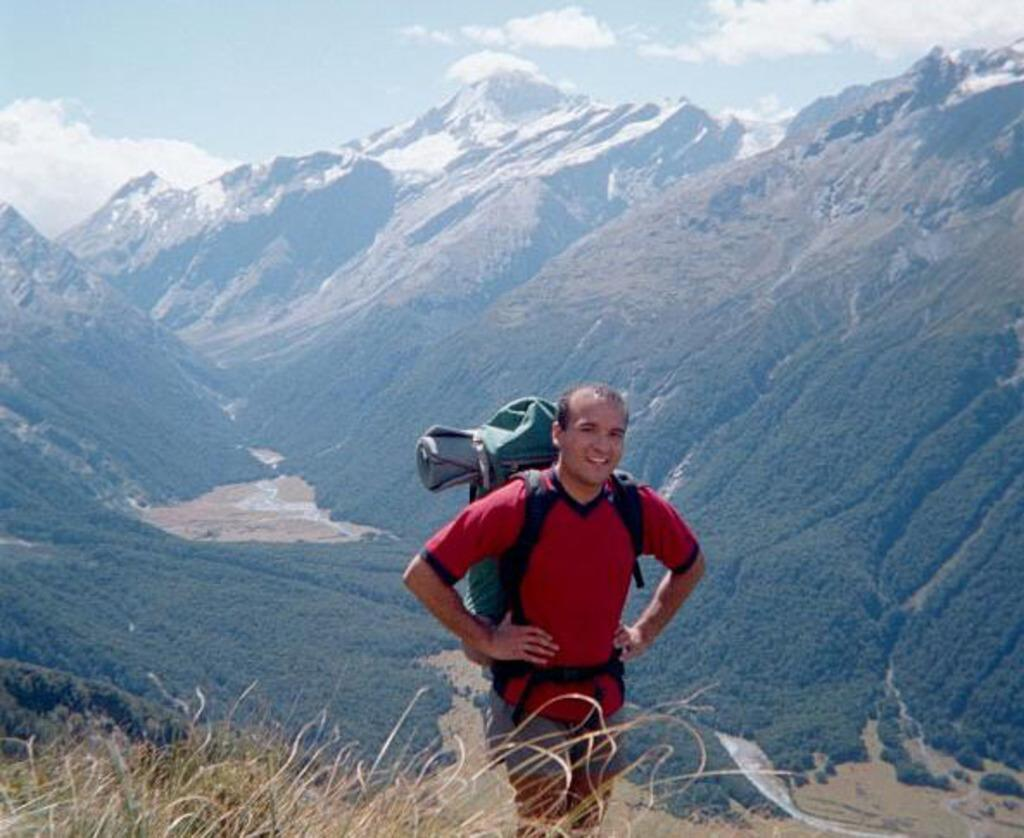Who or what is present in the image? There is a person in the image. What is the person wearing? The person is wearing a backpack. What is the person's posture in the image? The person is standing. What can be seen in the distance in the image? There are mountains visible in the background of the image. What type of toad can be seen hopping in the image? There is no toad present in the image; it features a person wearing a backpack and standing in front of mountains. 